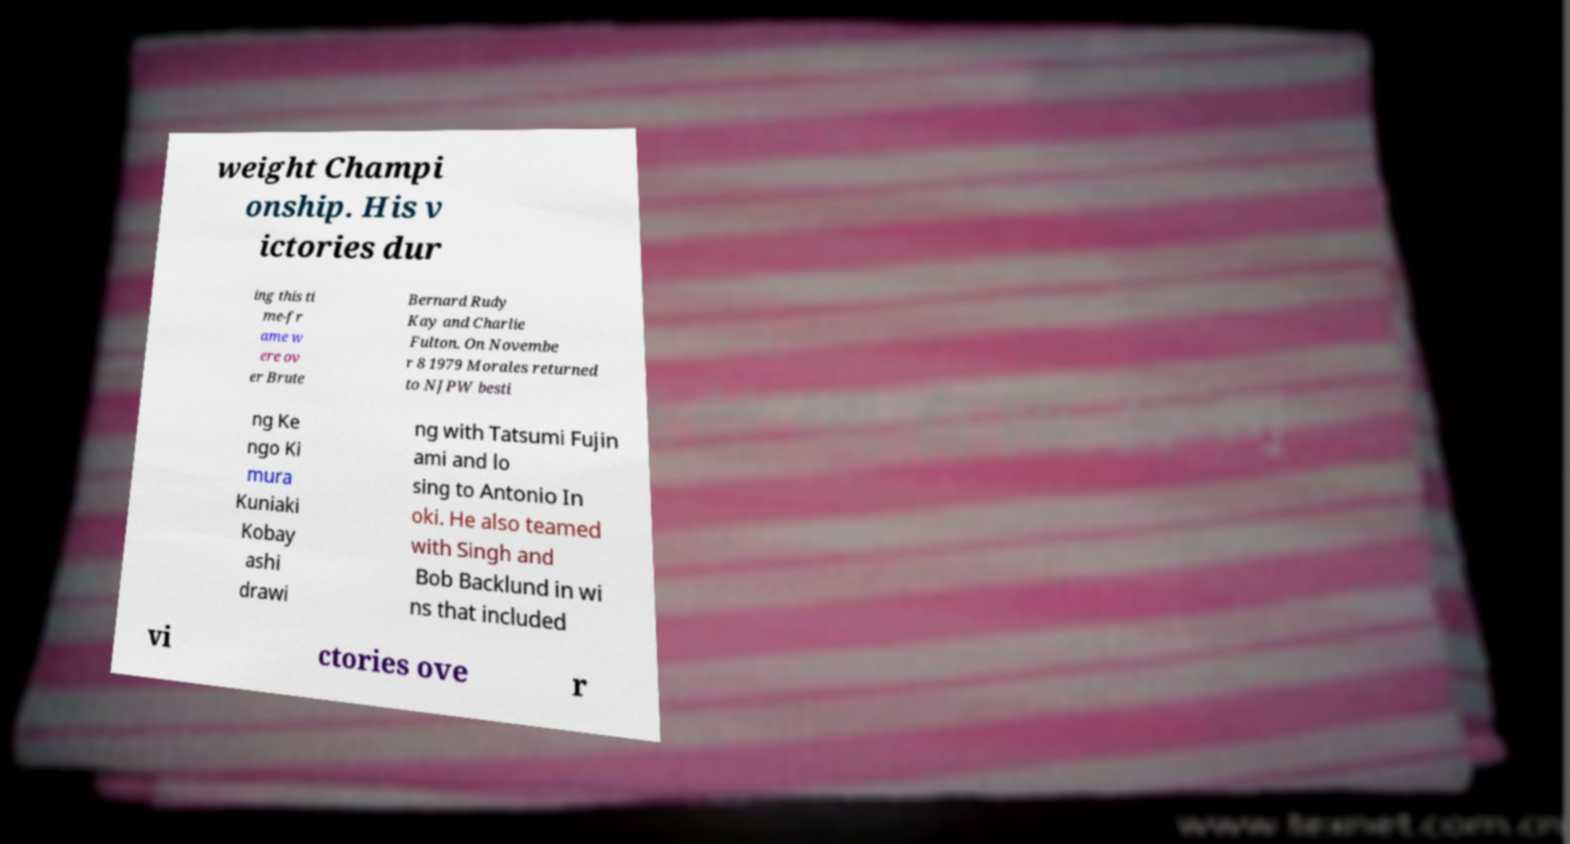What messages or text are displayed in this image? I need them in a readable, typed format. weight Champi onship. His v ictories dur ing this ti me-fr ame w ere ov er Brute Bernard Rudy Kay and Charlie Fulton. On Novembe r 8 1979 Morales returned to NJPW besti ng Ke ngo Ki mura Kuniaki Kobay ashi drawi ng with Tatsumi Fujin ami and lo sing to Antonio In oki. He also teamed with Singh and Bob Backlund in wi ns that included vi ctories ove r 